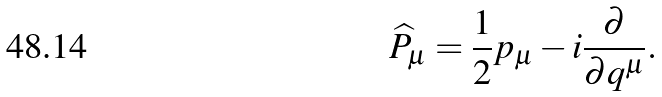<formula> <loc_0><loc_0><loc_500><loc_500>\widehat { P } _ { \mu } = \frac { 1 } { 2 } p _ { \mu } - i \frac { \partial } { \partial q ^ { \mu } } .</formula> 